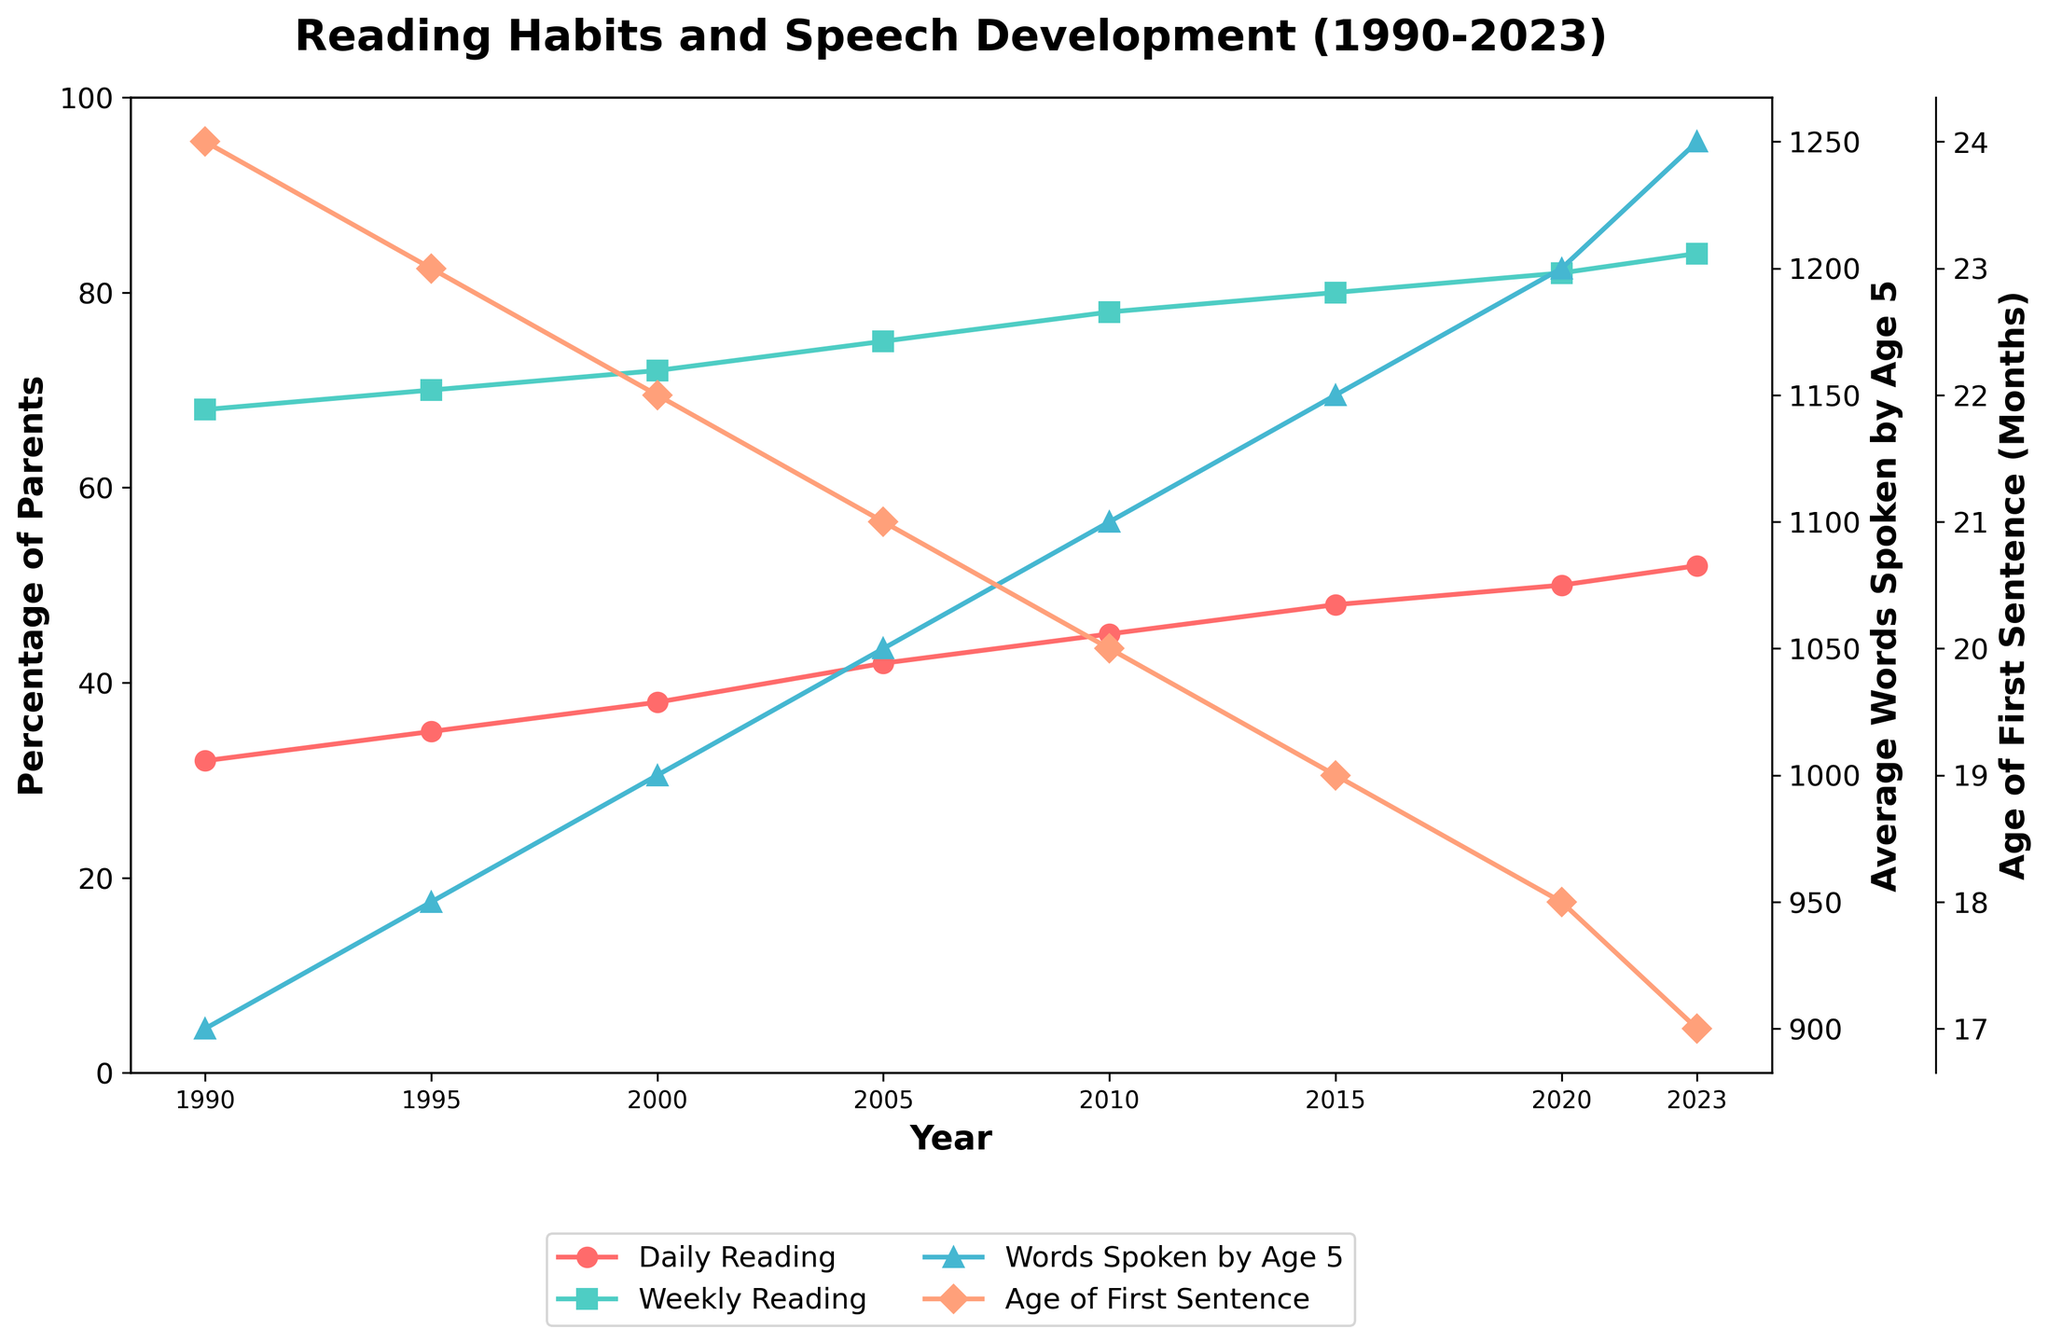How has the percentage of parents reading daily changed from 1990 to 2023? From the figure, the percentage of parents reading daily in 1990 was 32%. In 2023, this increased to 52%. Therefore, the change is 52% - 32% = 20%.
Answer: Increased by 20% Which year had the highest average number of words spoken by age 5? Looking at the line representing the average number of words spoken by age 5, we see the highest point is in 2023 with 1,250 words.
Answer: 2023 What is the trend observed for the age of the first sentence over the years? Observing the trend line for the age of the first sentence, the age has consistently decreased from 24 months in 1990 to 17 months in 2023 over the given years.
Answer: Decreasing trend Compare the percentage of parents reading weekly in 2000 and 2023. Which year has a higher percentage? The figure shows that in 2000, the percentage of parents reading weekly was 72%, and in 2023, it was 84%. Thus, 2023 has a higher percentage.
Answer: 2023 By how many months has the average age of the first sentence decreased from 1990 to 2023? The average age of the first sentence in 1990 was 24 months, and in 2023 it is 17 months. The decrease is 24 - 17 = 7 months.
Answer: 7 months What correlation can you observe between the daily reading habits of parents and the average number of words spoken by age 5? There is a positive correlation; as the percentage of parents reading daily increases, the average number of words spoken by age 5 also increases. For instance, daily reading increased from 32% to 52%, correspondingly the average words spoken increased from 900 to 1,250.
Answer: Positive correlation Which color line represents the age of the first sentence, and what is its trend? The line representing the age of the first sentence is marked in peach. The trend shows a consistent decrease from 24 months in 1990 to 17 months in 2023.
Answer: Peach, decreasing Is there a significant change in weekly reading habits of parents between 1990 and 2023? In 1990, weekly reading by parents was at 68%, while in 2023, it increased to 84%. The change is 84% - 68% = 16%. Yes, there is a significant increase.
Answer: Yes, increased by 16% How has the average number of words spoken by age 5 changed between 2010 and 2023? In 2010, the average words spoken was 1,100. In 2023, it increased to 1,250. Therefore, the change is 1,250 - 1,100 = 150 words.
Answer: Increased by 150 words What relationship is seen between the weekly reading habits of parents and the age of the first sentence? As the weekly reading percentage increases over the years, the age of the first sentence consistently decreases, suggesting that more frequent reading is associated with earlier speech development milestones.
Answer: Inversely related 